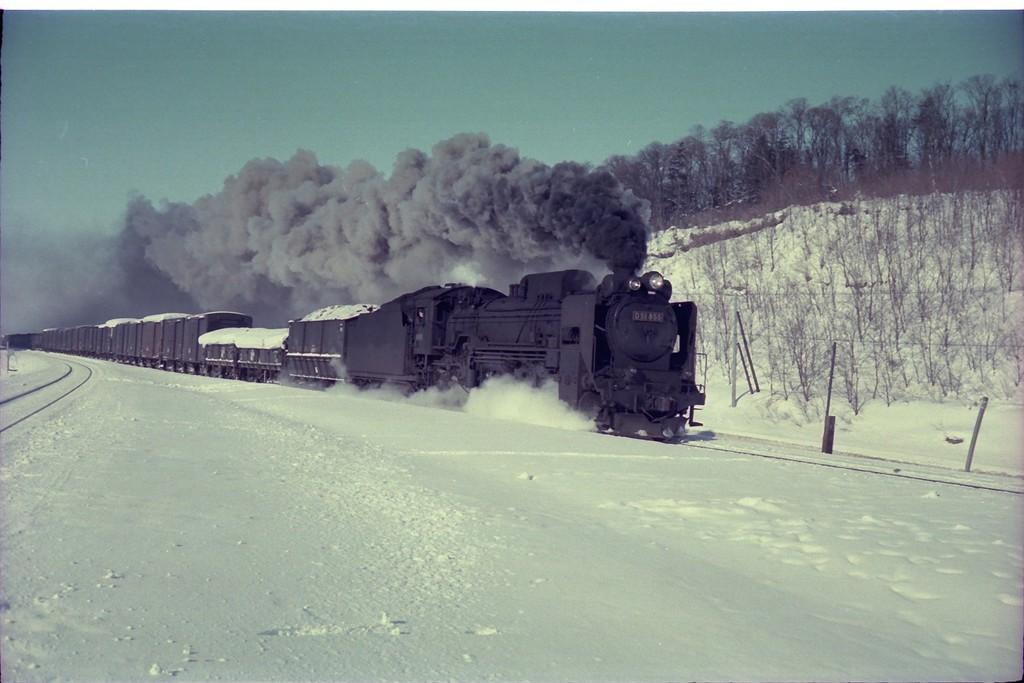Describe this image in one or two sentences. in the foreground there is snow. In the center of the picture there are railway tracks, fencing, trees and a train. At the top left it is sky. At the top right there are trees. In the center of the picture there is smoke. It is Sunny. 